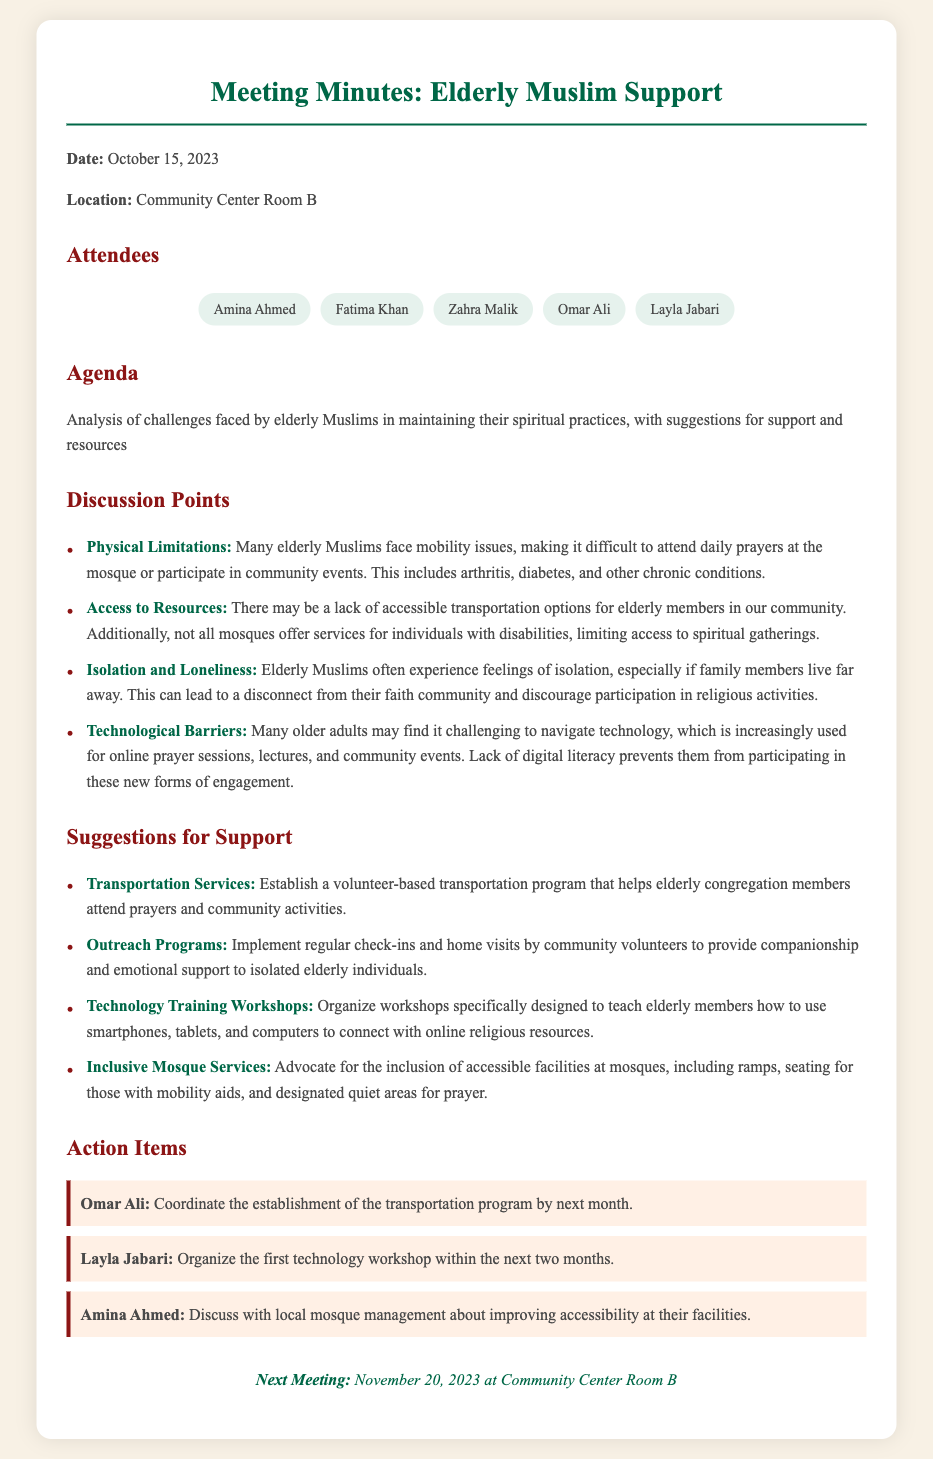What is the date of the meeting? The date of the meeting is stated at the beginning of the document.
Answer: October 15, 2023 Who is responsible for coordinating the transportation program? The action item lists that Omar Ali will coordinate the establishment of the transportation program.
Answer: Omar Ali What is one of the challenges faced by elderly Muslims? The document discusses several challenges, highlighting one specific issue here.
Answer: Mobility issues How many attendees were listed in the meeting? The number of attendees is calculated by counting the names listed in the attendees section.
Answer: Five When is the next meeting scheduled? The date of the next meeting is mentioned at the end of the document.
Answer: November 20, 2023 What is one suggestion for support mentioned in the meeting? The document lists suggestions for support, highlighting one that provides a solution for the discussed challenges.
Answer: Transportation Services What type of event is discussed in the agenda? The agenda outlines the main theme of the meeting, which relates to the elderly's engagement.
Answer: Support for elderly Muslims Which committee member is tasked with organizing technology workshops? The specific responsibility for organizing technology workshops is attributed to one of the attendees in the action items.
Answer: Layla Jabari 